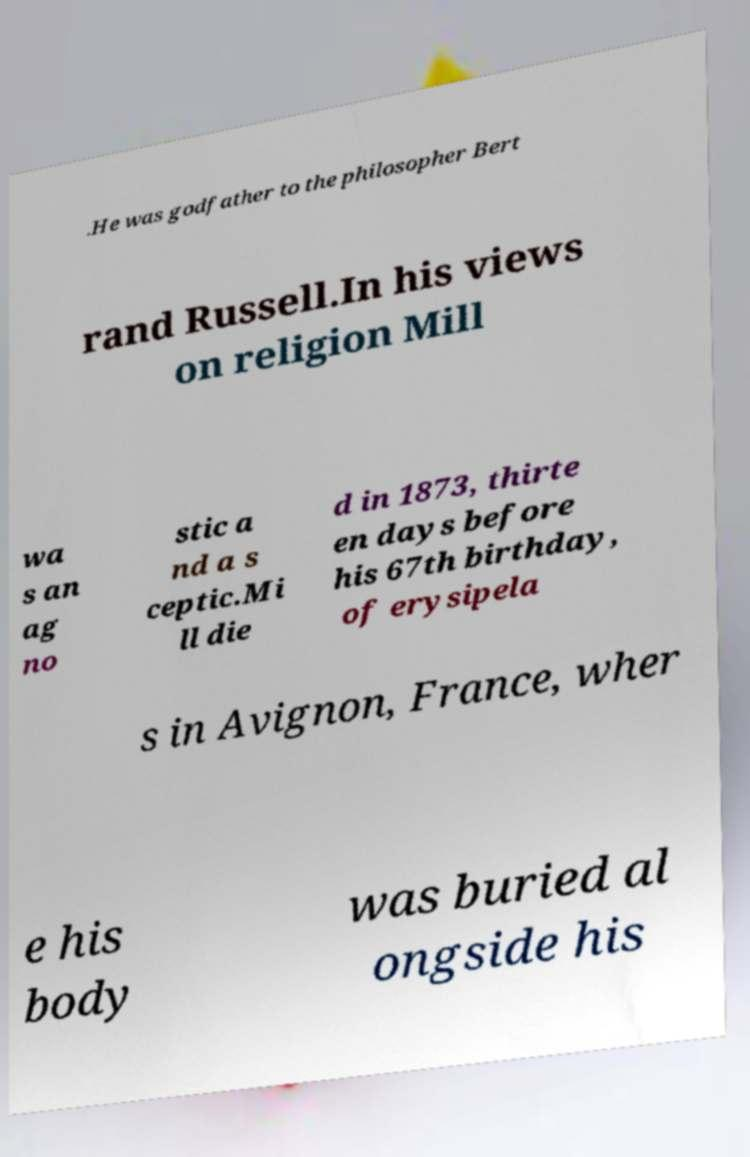Please identify and transcribe the text found in this image. .He was godfather to the philosopher Bert rand Russell.In his views on religion Mill wa s an ag no stic a nd a s ceptic.Mi ll die d in 1873, thirte en days before his 67th birthday, of erysipela s in Avignon, France, wher e his body was buried al ongside his 